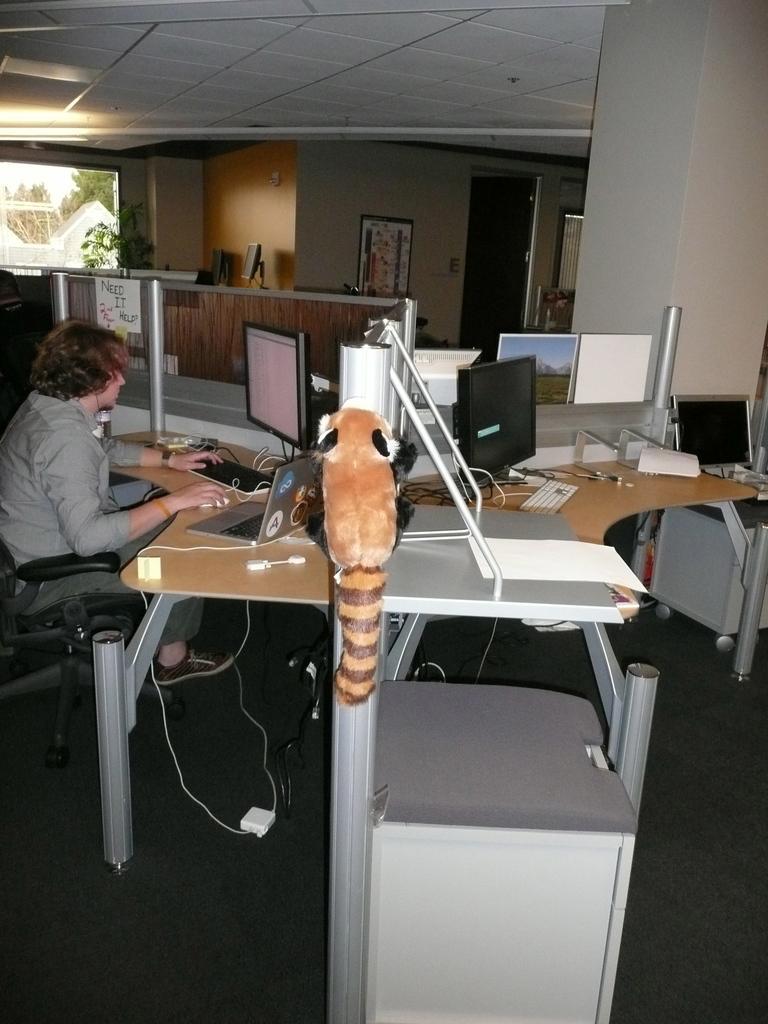Describe this image in one or two sentences. in a room there are desks. in the left a person is sitting on a chair and operating computer. right to that computer there is a laptop and a cable. at the right there is a paper on the desk and a soft toy is placed in the center. behind that there is a wall, plant and a window at the left. 